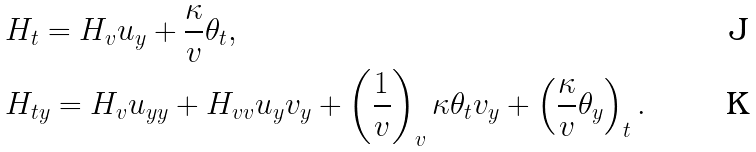Convert formula to latex. <formula><loc_0><loc_0><loc_500><loc_500>& H _ { t } = H _ { v } u _ { y } + \frac { \kappa } { v } \theta _ { t } , \\ & H _ { t y } = H _ { v } u _ { y y } + H _ { v v } u _ { y } v _ { y } + \left ( \frac { 1 } { v } \right ) _ { v } \kappa \theta _ { t } v _ { y } + \left ( \frac { \kappa } { v } \theta _ { y } \right ) _ { t } .</formula> 